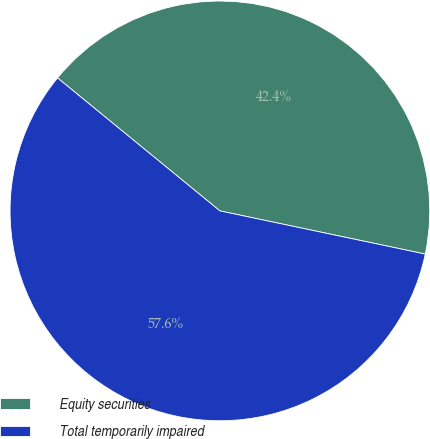Convert chart to OTSL. <chart><loc_0><loc_0><loc_500><loc_500><pie_chart><fcel>Equity securities<fcel>Total temporarily impaired<nl><fcel>42.38%<fcel>57.62%<nl></chart> 